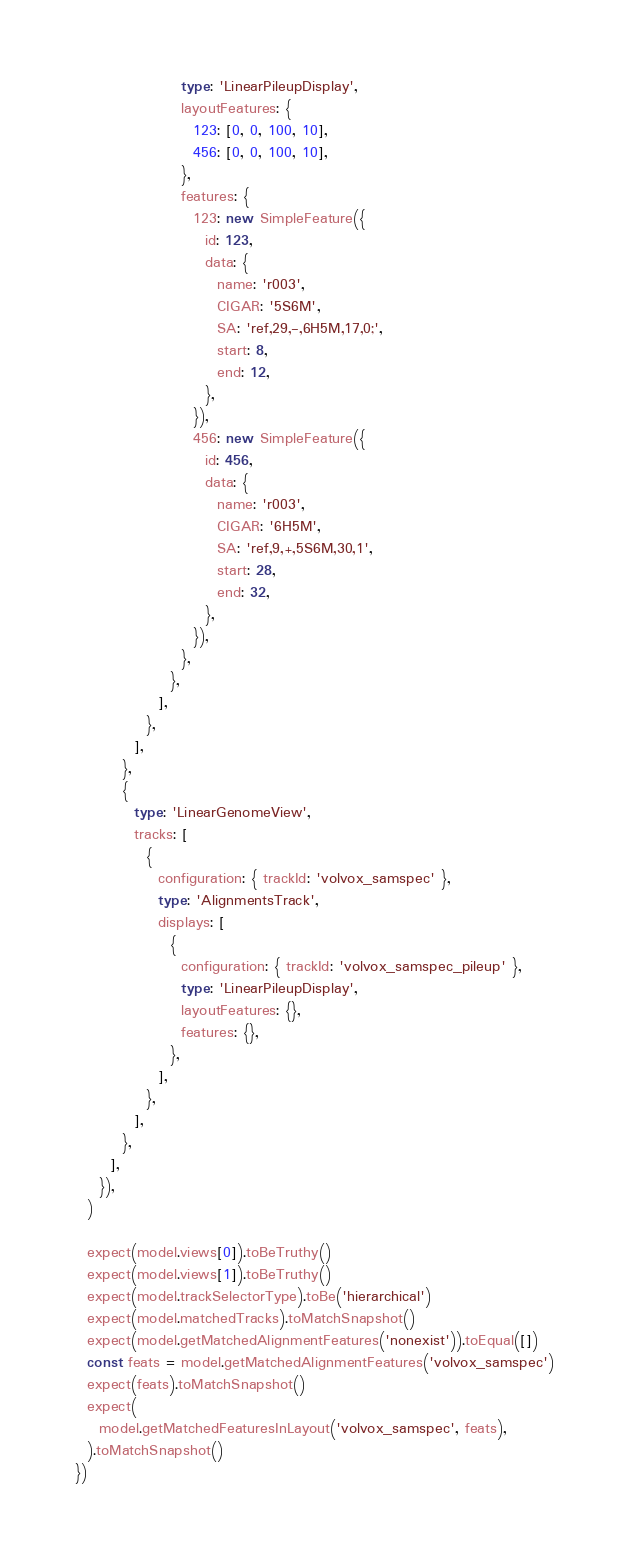Convert code to text. <code><loc_0><loc_0><loc_500><loc_500><_TypeScript_>                  type: 'LinearPileupDisplay',
                  layoutFeatures: {
                    123: [0, 0, 100, 10],
                    456: [0, 0, 100, 10],
                  },
                  features: {
                    123: new SimpleFeature({
                      id: 123,
                      data: {
                        name: 'r003',
                        CIGAR: '5S6M',
                        SA: 'ref,29,-,6H5M,17,0;',
                        start: 8,
                        end: 12,
                      },
                    }),
                    456: new SimpleFeature({
                      id: 456,
                      data: {
                        name: 'r003',
                        CIGAR: '6H5M',
                        SA: 'ref,9,+,5S6M,30,1',
                        start: 28,
                        end: 32,
                      },
                    }),
                  },
                },
              ],
            },
          ],
        },
        {
          type: 'LinearGenomeView',
          tracks: [
            {
              configuration: { trackId: 'volvox_samspec' },
              type: 'AlignmentsTrack',
              displays: [
                {
                  configuration: { trackId: 'volvox_samspec_pileup' },
                  type: 'LinearPileupDisplay',
                  layoutFeatures: {},
                  features: {},
                },
              ],
            },
          ],
        },
      ],
    }),
  )

  expect(model.views[0]).toBeTruthy()
  expect(model.views[1]).toBeTruthy()
  expect(model.trackSelectorType).toBe('hierarchical')
  expect(model.matchedTracks).toMatchSnapshot()
  expect(model.getMatchedAlignmentFeatures('nonexist')).toEqual([])
  const feats = model.getMatchedAlignmentFeatures('volvox_samspec')
  expect(feats).toMatchSnapshot()
  expect(
    model.getMatchedFeaturesInLayout('volvox_samspec', feats),
  ).toMatchSnapshot()
})
</code> 